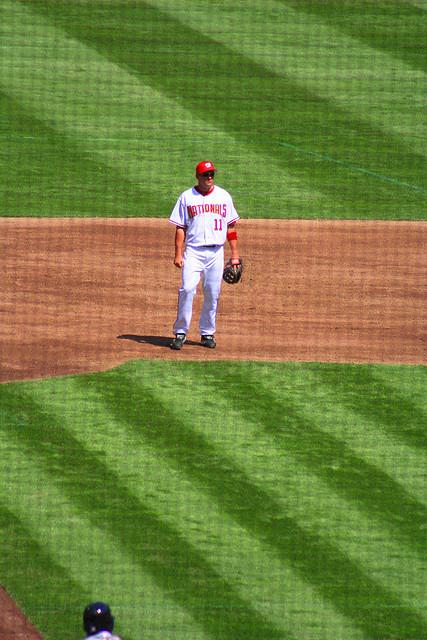What game are the men playing?
Give a very brief answer. Baseball. Is this man preparing to hit a ball?
Be succinct. No. What color is the fielder's hat?
Concise answer only. Red. 